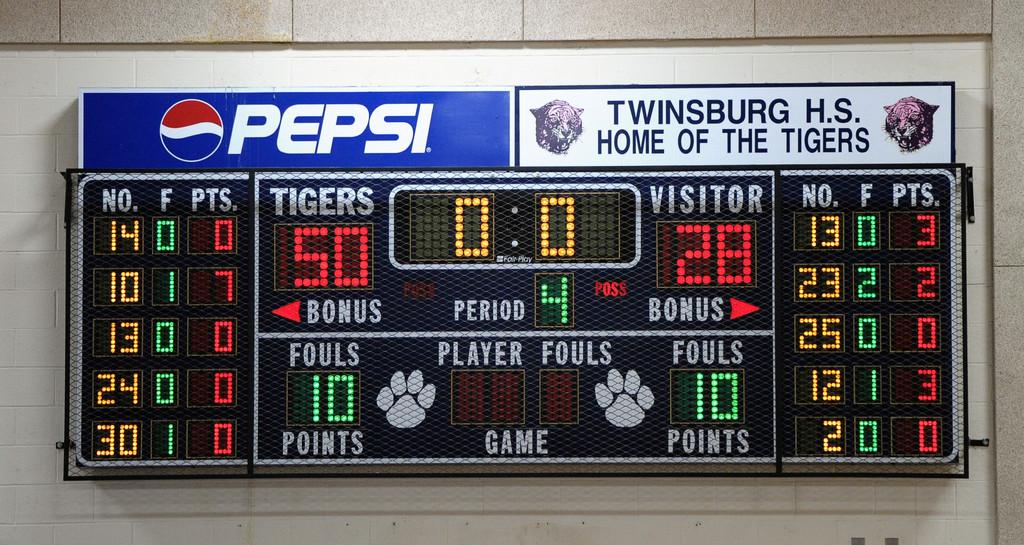What is the visitor's score?
Offer a very short reply. 28. What soda sponsor is on the top?
Your answer should be compact. Pepsi. 